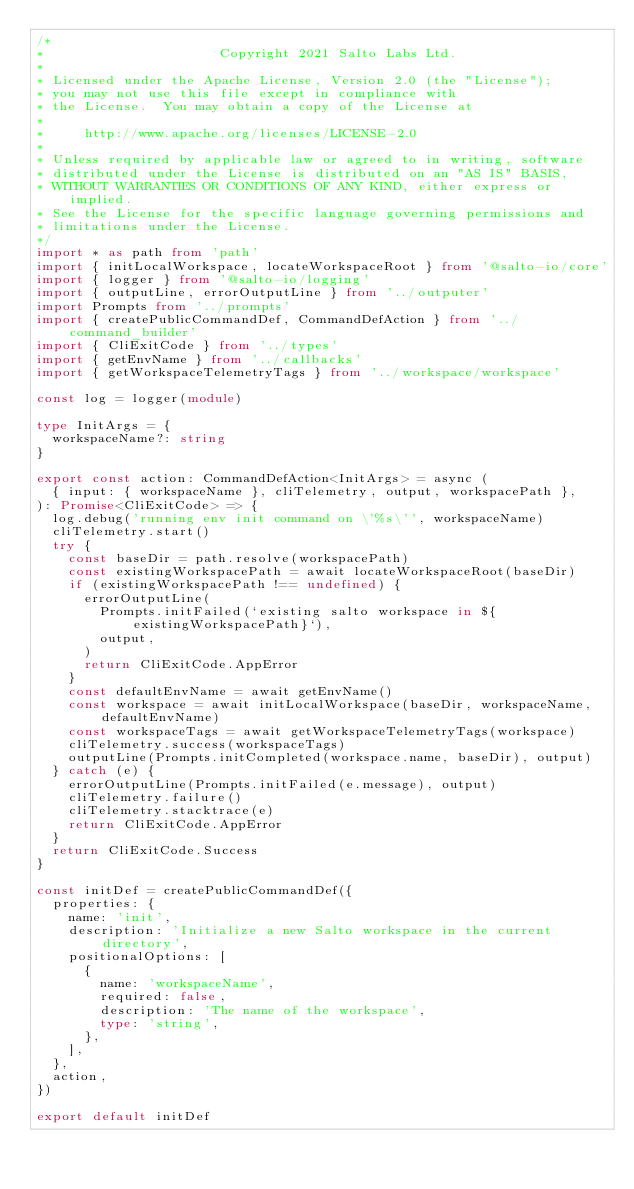<code> <loc_0><loc_0><loc_500><loc_500><_TypeScript_>/*
*                      Copyright 2021 Salto Labs Ltd.
*
* Licensed under the Apache License, Version 2.0 (the "License");
* you may not use this file except in compliance with
* the License.  You may obtain a copy of the License at
*
*     http://www.apache.org/licenses/LICENSE-2.0
*
* Unless required by applicable law or agreed to in writing, software
* distributed under the License is distributed on an "AS IS" BASIS,
* WITHOUT WARRANTIES OR CONDITIONS OF ANY KIND, either express or implied.
* See the License for the specific language governing permissions and
* limitations under the License.
*/
import * as path from 'path'
import { initLocalWorkspace, locateWorkspaceRoot } from '@salto-io/core'
import { logger } from '@salto-io/logging'
import { outputLine, errorOutputLine } from '../outputer'
import Prompts from '../prompts'
import { createPublicCommandDef, CommandDefAction } from '../command_builder'
import { CliExitCode } from '../types'
import { getEnvName } from '../callbacks'
import { getWorkspaceTelemetryTags } from '../workspace/workspace'

const log = logger(module)

type InitArgs = {
  workspaceName?: string
}

export const action: CommandDefAction<InitArgs> = async (
  { input: { workspaceName }, cliTelemetry, output, workspacePath },
): Promise<CliExitCode> => {
  log.debug('running env init command on \'%s\'', workspaceName)
  cliTelemetry.start()
  try {
    const baseDir = path.resolve(workspacePath)
    const existingWorkspacePath = await locateWorkspaceRoot(baseDir)
    if (existingWorkspacePath !== undefined) {
      errorOutputLine(
        Prompts.initFailed(`existing salto workspace in ${existingWorkspacePath}`),
        output,
      )
      return CliExitCode.AppError
    }
    const defaultEnvName = await getEnvName()
    const workspace = await initLocalWorkspace(baseDir, workspaceName, defaultEnvName)
    const workspaceTags = await getWorkspaceTelemetryTags(workspace)
    cliTelemetry.success(workspaceTags)
    outputLine(Prompts.initCompleted(workspace.name, baseDir), output)
  } catch (e) {
    errorOutputLine(Prompts.initFailed(e.message), output)
    cliTelemetry.failure()
    cliTelemetry.stacktrace(e)
    return CliExitCode.AppError
  }
  return CliExitCode.Success
}

const initDef = createPublicCommandDef({
  properties: {
    name: 'init',
    description: 'Initialize a new Salto workspace in the current directory',
    positionalOptions: [
      {
        name: 'workspaceName',
        required: false,
        description: 'The name of the workspace',
        type: 'string',
      },
    ],
  },
  action,
})

export default initDef
</code> 